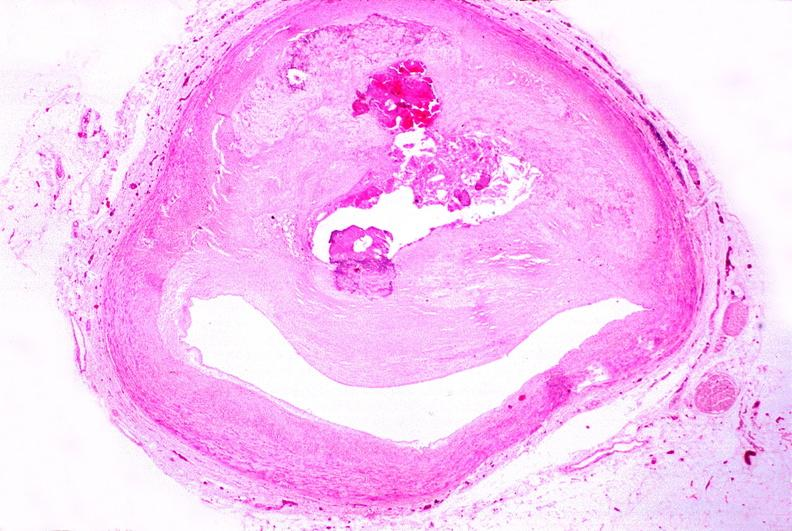what does this image show?
Answer the question using a single word or phrase. Atherosclerosis 